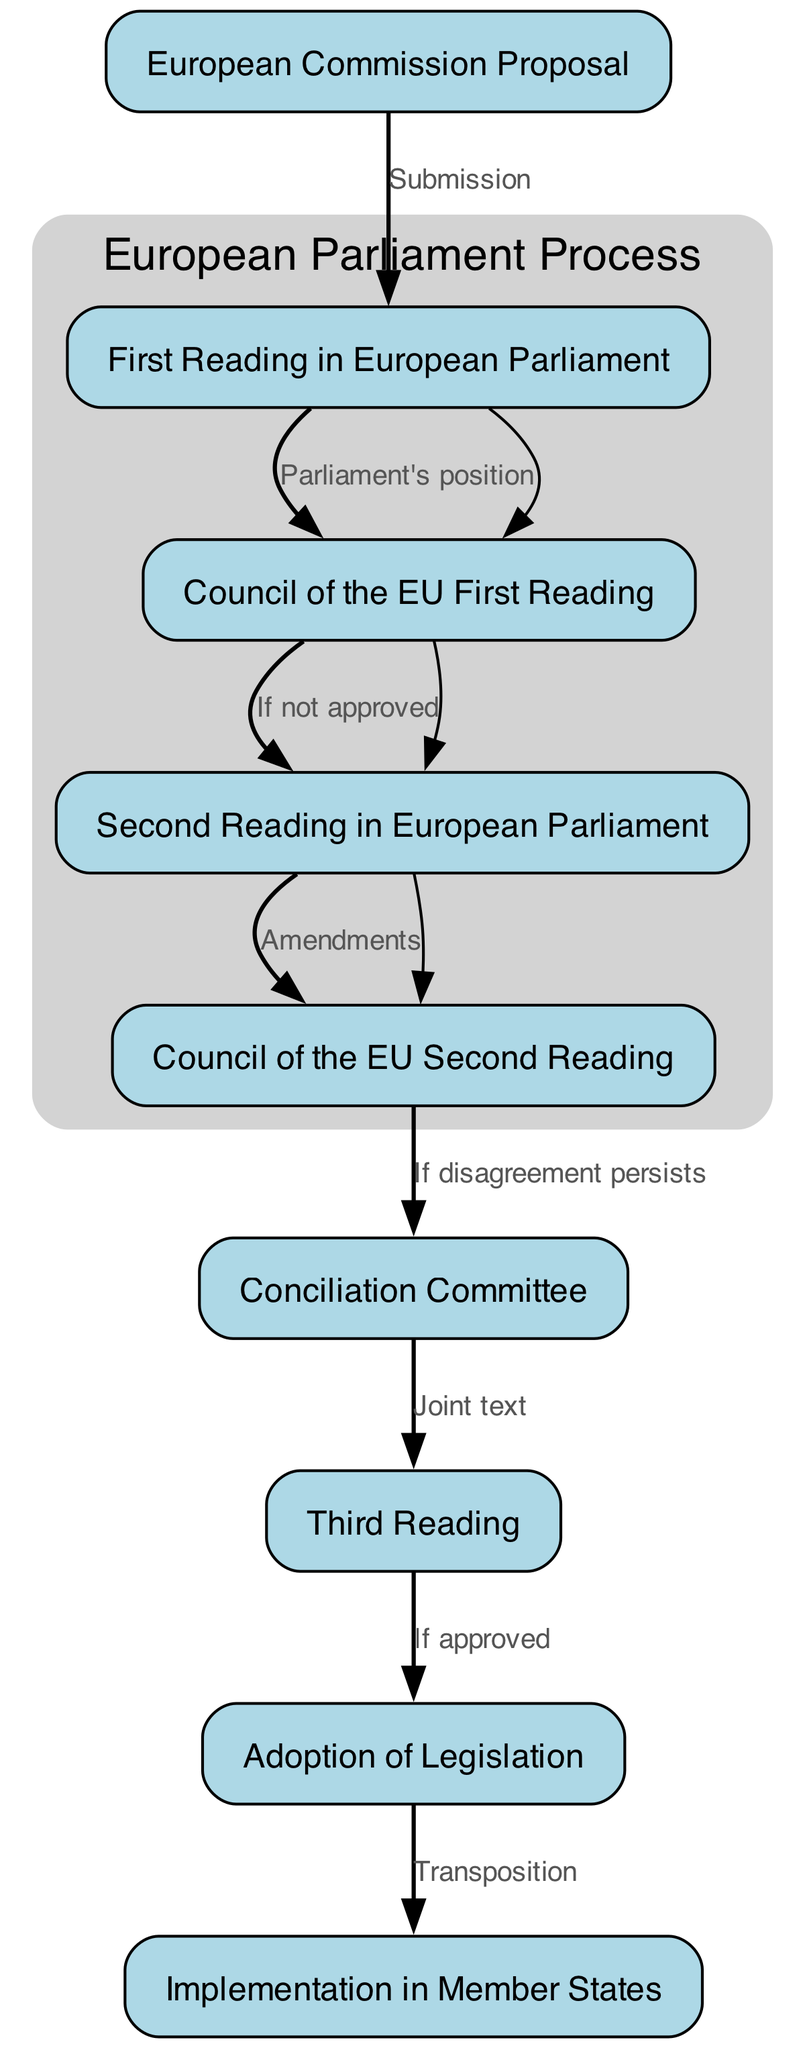What is the first step in the legislative process? The first node in the diagram is "European Commission Proposal," which indicates that this is the initial step in the legislative process.
Answer: European Commission Proposal How many nodes are in the diagram? By counting each unique labeled node in the diagram, we find that there are a total of nine nodes present.
Answer: Nine What does the second reading in the European Parliament lead to? The edge from the "Second Reading in European Parliament" node points to the "Council of the EU Second Reading," indicating that the second reading leads to this step if it is not approved.
Answer: Council of the EU Second Reading What is the function of the Conciliation Committee? The diagram shows that if there is persistent disagreement between the Council and Parliament, the "Conciliation Committee" is convened to prepare a joint text.
Answer: Joint text How many edges are there in the diagram? Counting all the connections between the nodes, we find that there are a total of eight edges illustrated in the diagram.
Answer: Eight What happens after the Adoption of Legislation? The edge from the "Adoption of Legislation" node leads to the "Implementation in Member States," indicating that after legislation is adopted, it must be implemented in member states.
Answer: Implementation in Member States What indicates that the Council disagreed with the Parliament? The edge that connects "Council of the EU First Reading" to "Second Reading in European Parliament" is labeled "If not approved,” which signifies that Council disagreement triggers a second reading in the Parliament.
Answer: If not approved What is the final step in the legislative process depicted in the diagram? The last node in the flowchart is "Implementation in Member States," which indicates that this is the final step in the legislative process after legislation is adopted.
Answer: Implementation in Member States 